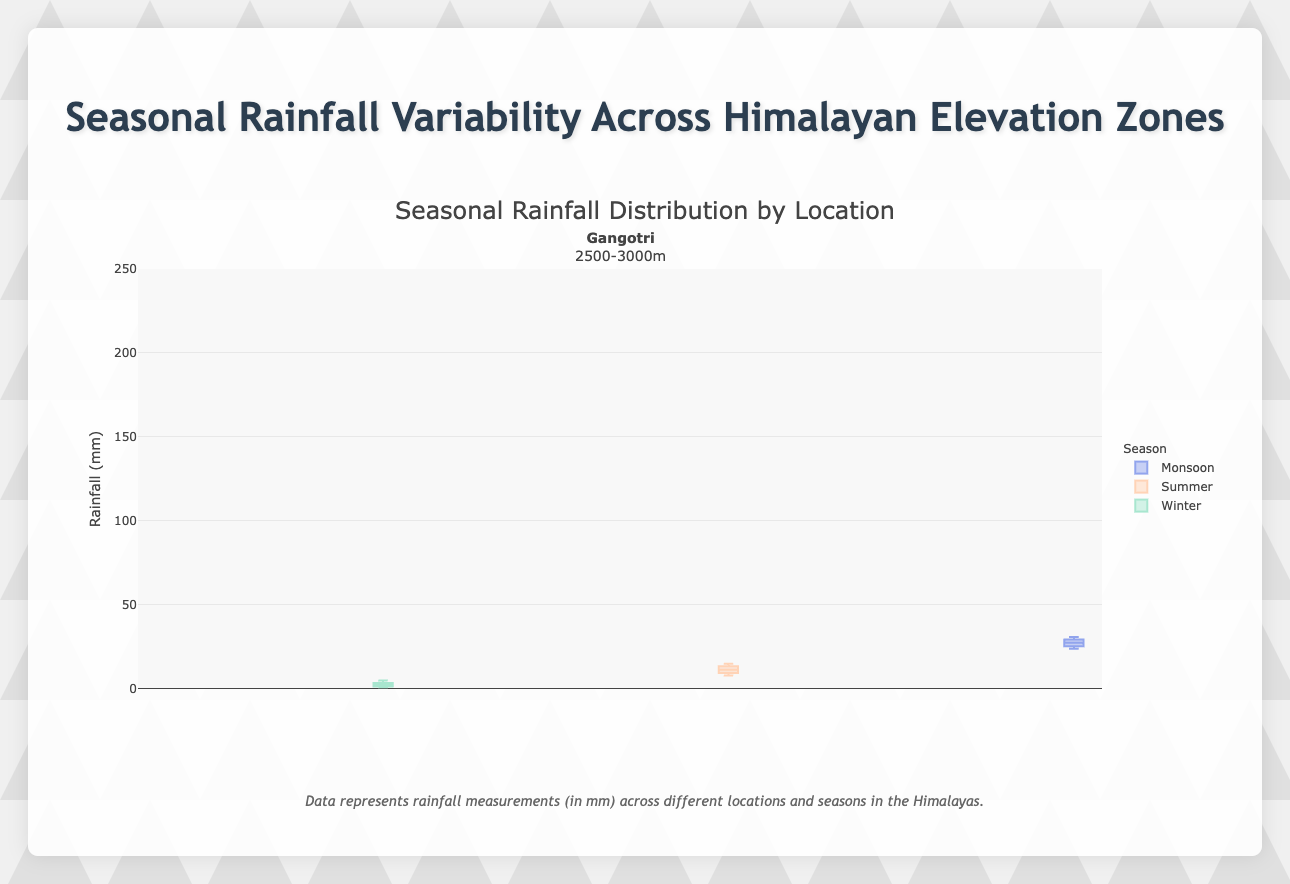What is the range of rainfall values for Winter in Gangotri? The box plot for Winter in Gangotri shows rainfall values from the minimum to the maximum. Visually, the lowest value is 11 mm, and the highest value is 20 mm, so the range is 20 - 11.
Answer: 9 mm Which location has the highest median rainfall during the Monsoon season? By comparing the median lines within the box plots for Monsoon across all locations, it is clear that Nainital has the highest median value.
Answer: Nainital What is the interquartile range (IQR) for Summer in Manali? The IQR is the difference between the third quartile (Q3) and the first quartile (Q1). For Summer in Manali, Q3 is approximately 63 and Q1 is approximately 59 from the box plot.
Answer: 4 mm During which season does Leh experience the least rainfall variability? The box plot for Leh in Winter has the smallest spread, indicating the least variability in rainfall. This is visible from the size of the box and the range of the whiskers.
Answer: Winter Compare the median rainfall values of Summer between Nainital and Manali. Which location receives more rainfall? By comparing the median lines within the Summer box plots for Nainital and Manali, Nainital's median is higher than Manali's.
Answer: Nainital What outlier values are observed for Winter in Leh? The box plot for Winter in Leh has outliers marked with points beyond the whiskers. The outliers for Winter in Leh are 1 mm and 5 mm.
Answer: 1 mm, 5 mm How does the median rainfall in Summer in Leh compare to Winter in Gangotri? By comparing the medians, the summer median rainfall in Leh appears higher than the winter median rainfall in Gangotri, visible by the relative positions of the median lines.
Answer: Higher Which season demonstrates the highest variability in rainfall for Manali? The box plot with the greatest spread (longer box and whiskers) for Manali indicates the highest variability. This is observed for the Monsoon season.
Answer: Monsoon Is there any season in Nainital where rainfall is consistently above 200 mm? For the Monsoon season in Nainital, all values, including the minimum whisker point, are above 200 mm, indicating consistent rainfall above this value.
Answer: Yes 